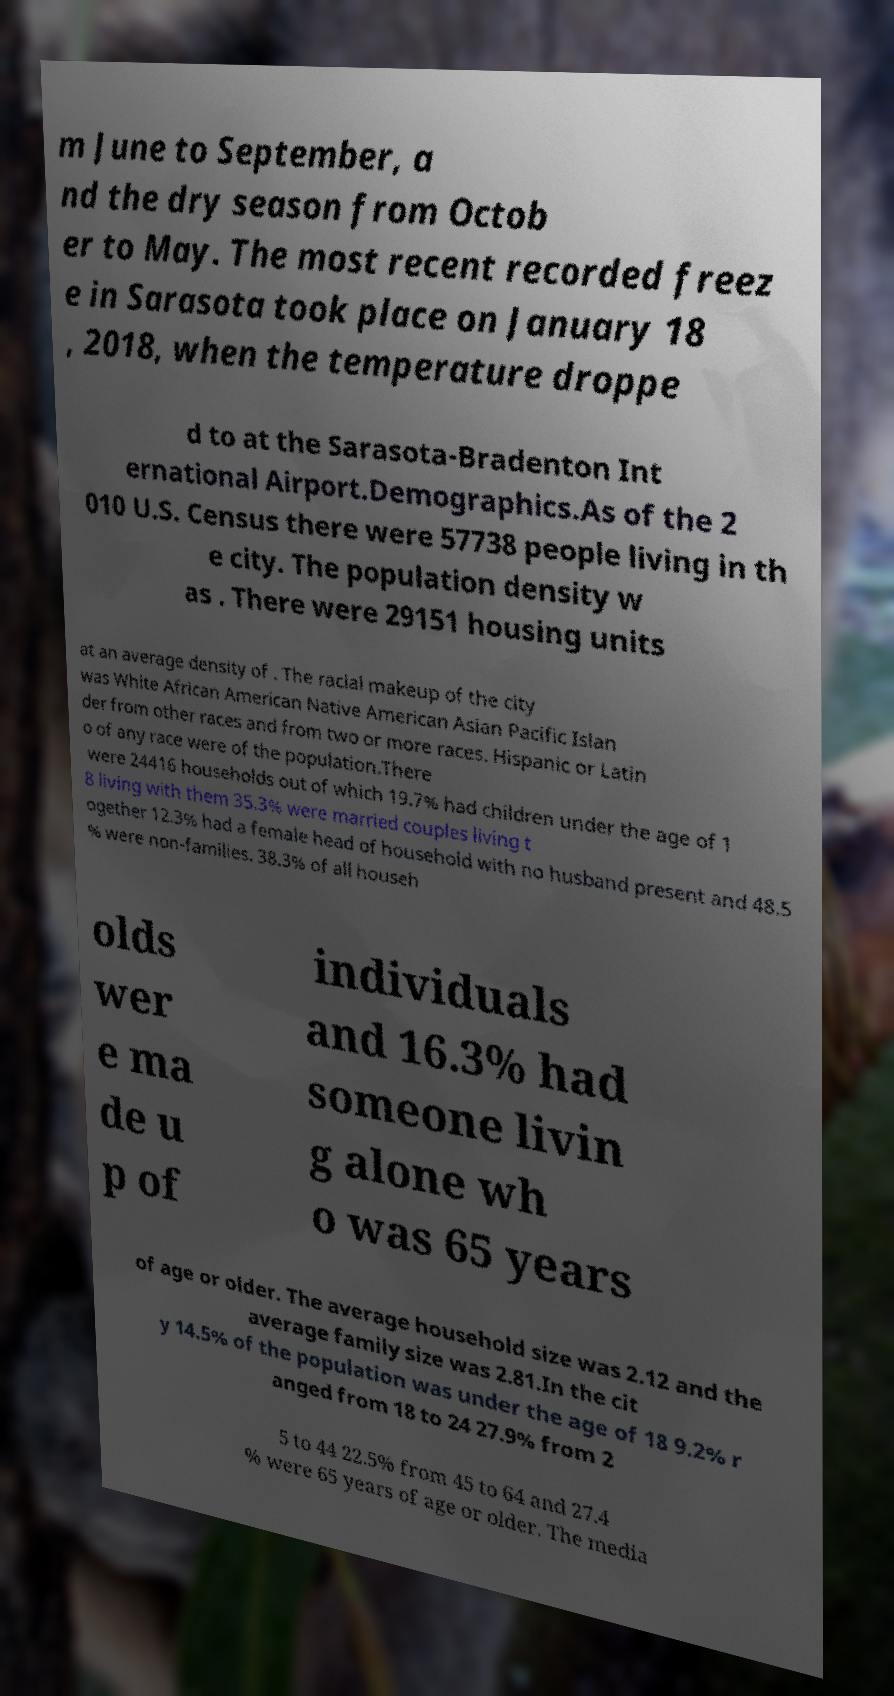For documentation purposes, I need the text within this image transcribed. Could you provide that? m June to September, a nd the dry season from Octob er to May. The most recent recorded freez e in Sarasota took place on January 18 , 2018, when the temperature droppe d to at the Sarasota-Bradenton Int ernational Airport.Demographics.As of the 2 010 U.S. Census there were 57738 people living in th e city. The population density w as . There were 29151 housing units at an average density of . The racial makeup of the city was White African American Native American Asian Pacific Islan der from other races and from two or more races. Hispanic or Latin o of any race were of the population.There were 24416 households out of which 19.7% had children under the age of 1 8 living with them 35.3% were married couples living t ogether 12.3% had a female head of household with no husband present and 48.5 % were non-families. 38.3% of all househ olds wer e ma de u p of individuals and 16.3% had someone livin g alone wh o was 65 years of age or older. The average household size was 2.12 and the average family size was 2.81.In the cit y 14.5% of the population was under the age of 18 9.2% r anged from 18 to 24 27.9% from 2 5 to 44 22.5% from 45 to 64 and 27.4 % were 65 years of age or older. The media 